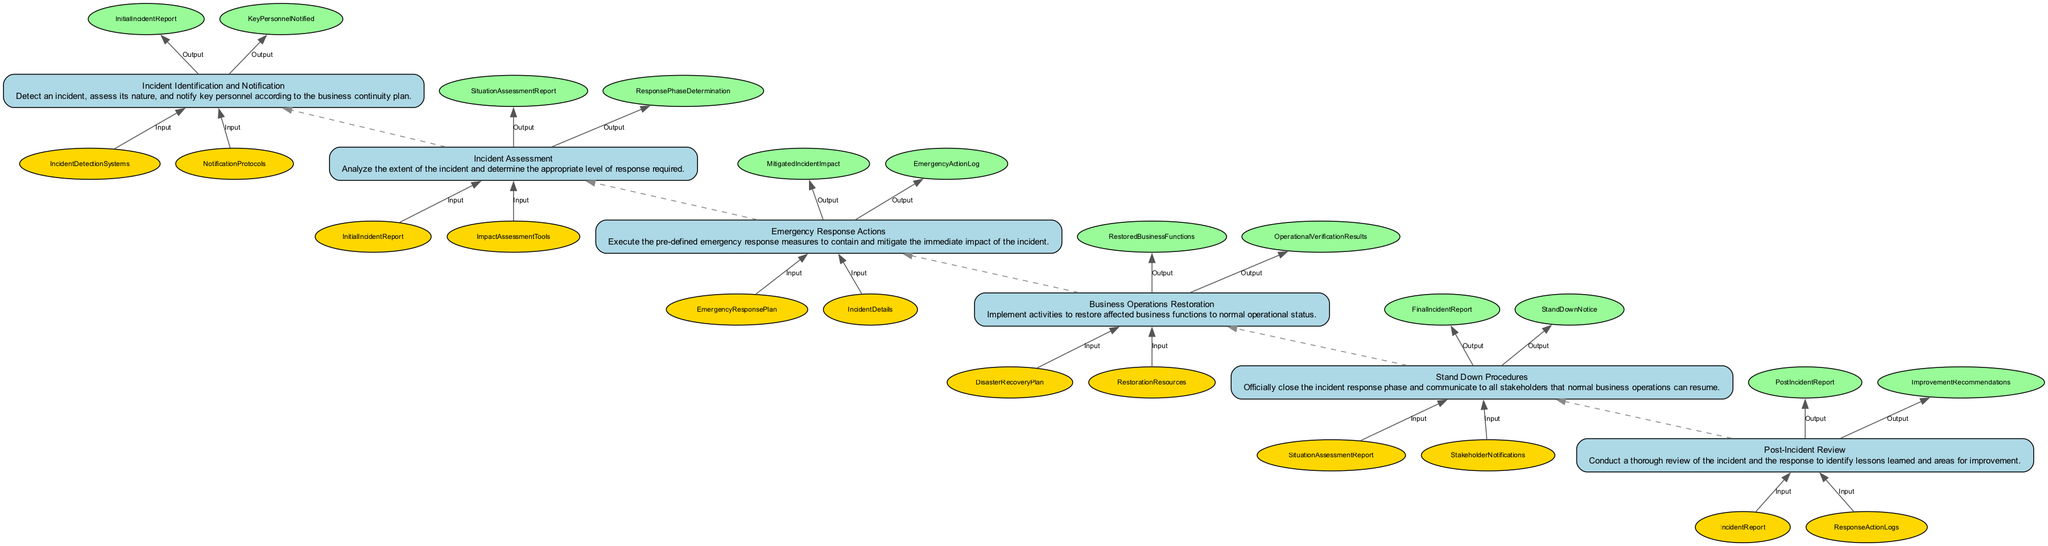What is the final step in the Business Continuity Plan Activation? The final step is "Post-Incident Review," which is positioned at the top of the flowchart.
Answer: Post-Incident Review How many steps are there in total for the Business Continuity Plan Activation? By counting each distinct step in the flowchart, we find there are six steps numbered from step one to step six.
Answer: 6 What are the inputs for the "Business Operations Restoration" step? The inputs for "Business Operations Restoration" are listed as "DisasterRecoveryPlan" and "RestorationResources" in the flowchart.
Answer: DisasterRecoveryPlan, RestorationResources Which step follows "Emergency Response Actions"? By following the flow direction from bottom to top in the diagram, "Incident Assessment" directly follows "Emergency Response Actions."
Answer: Incident Assessment What outputs are generated from the "Incident Identification and Notification" step? The outputs from the "Incident Identification and Notification" step include "InitialIncidentReport" and "KeyPersonnelNotified," as shown in the diagram.
Answer: InitialIncidentReport, KeyPersonnelNotified What is the main purpose of the "Post-Incident Review" step? The purpose of "Post-Incident Review" is to conduct a thorough review of the incident and the response to identify lessons learned and areas for improvement, which is explicitly stated in the flowchart.
Answer: Identify lessons learned and areas for improvement How many inputs are associated with the "Stand Down Procedures"? Counting the inputs listed for "Stand Down Procedures," which are "SituationAssessmentReport" and "StakeholderNotifications," it can be confirmed that there are two inputs.
Answer: 2 Which step is immediately before "Business Operations Restoration"? The step that directly precedes "Business Operations Restoration," as indicated in the flow direction, is "Emergency Response Actions."
Answer: Emergency Response Actions What is the relationship between "Incident Assessment" and "Emergency Response Actions"? "Incident Assessment" is an earlier step that provides outputs to the "Emergency Response Actions" step, necessitating its results to determine required actions.
Answer: Output to Input relationship What output is produced by the "Business Operations Restoration"? The outputs produced from the "Business Operations Restoration" step are listed as "RestoredBusinessFunctions" and "OperationalVerificationResults" in the flowchart.
Answer: RestoredBusinessFunctions, OperationalVerificationResults 